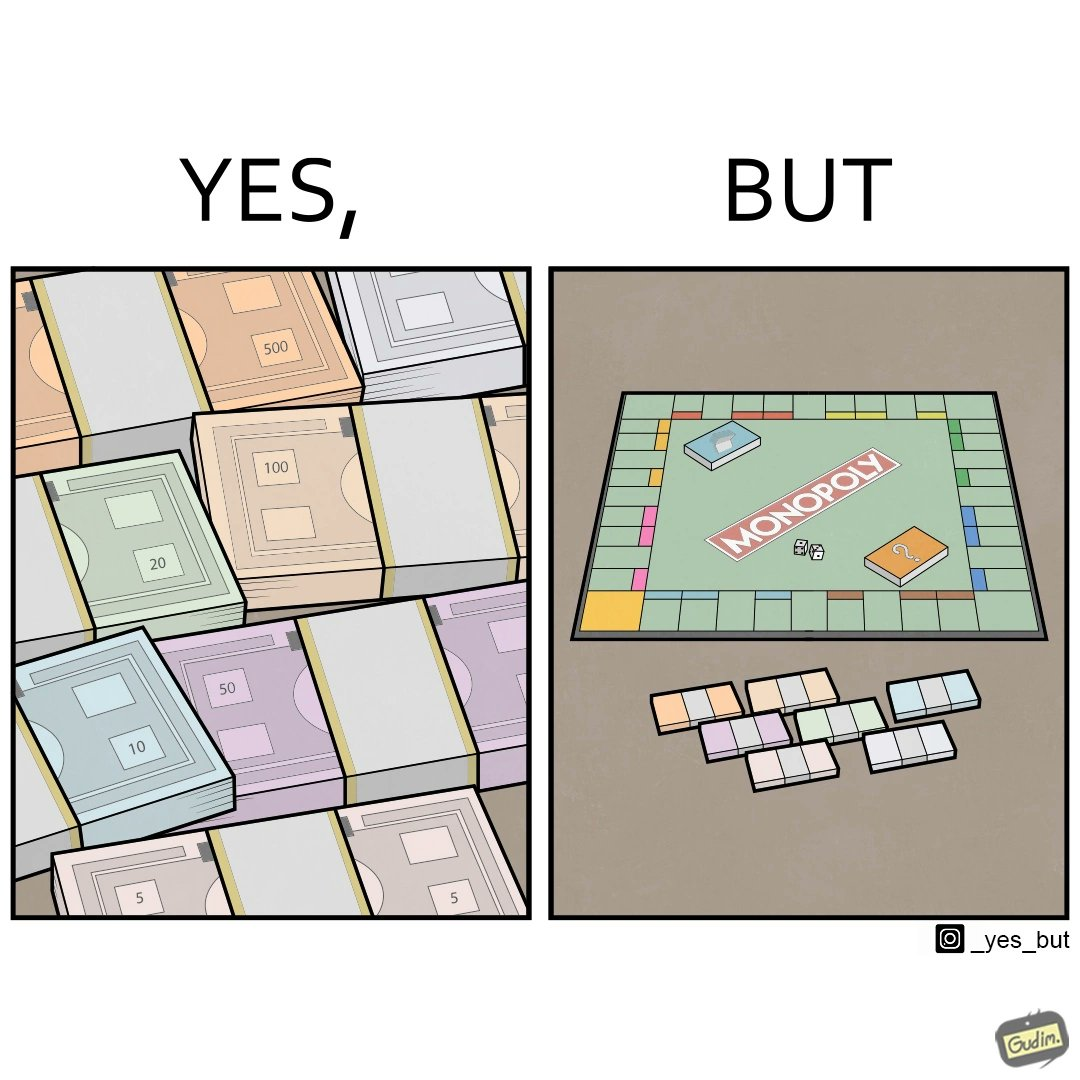Is this image satirical or non-satirical? Yes, this image is satirical. 